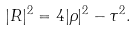Convert formula to latex. <formula><loc_0><loc_0><loc_500><loc_500>| R | ^ { 2 } = 4 | \rho | ^ { 2 } - \tau ^ { 2 } .</formula> 